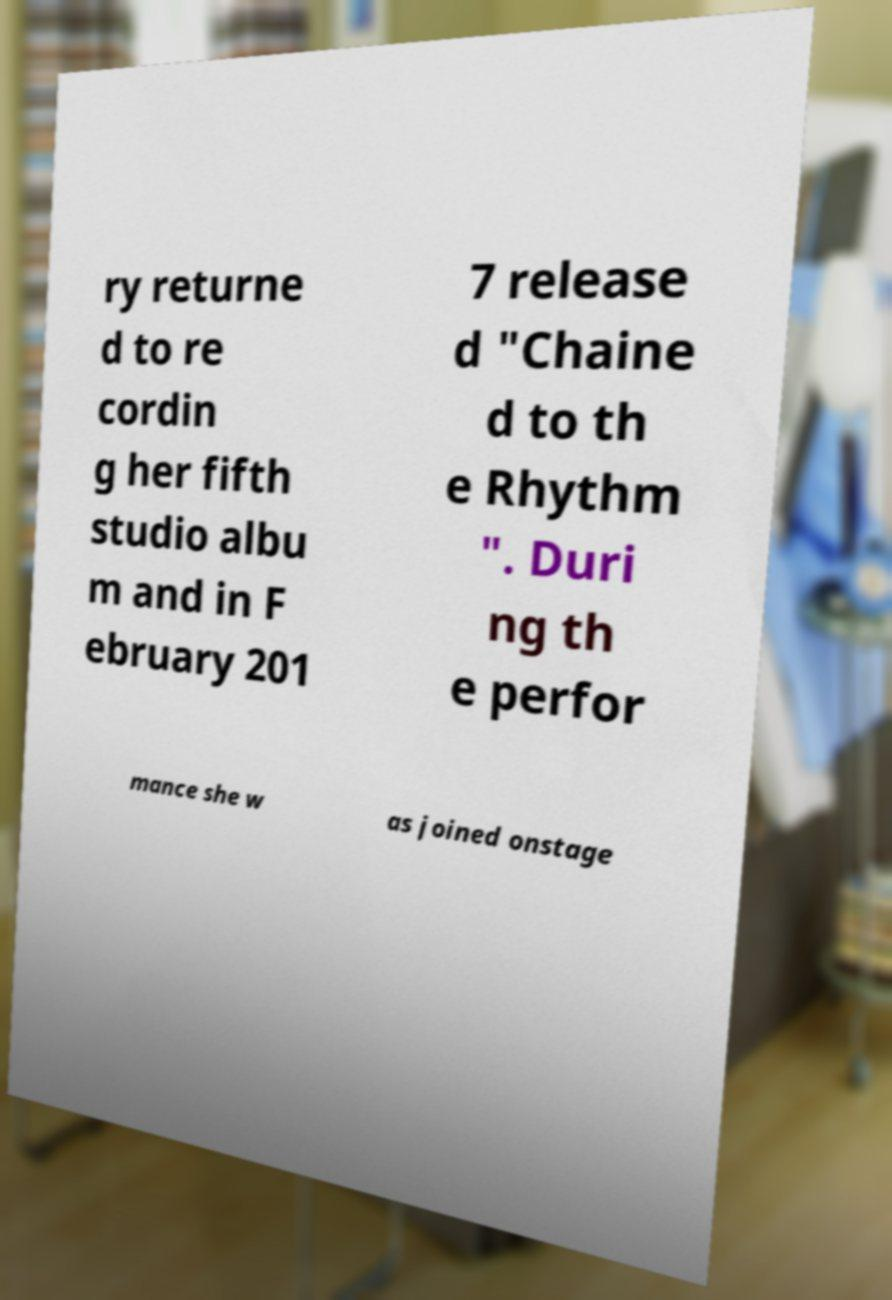Can you read and provide the text displayed in the image?This photo seems to have some interesting text. Can you extract and type it out for me? ry returne d to re cordin g her fifth studio albu m and in F ebruary 201 7 release d "Chaine d to th e Rhythm ". Duri ng th e perfor mance she w as joined onstage 